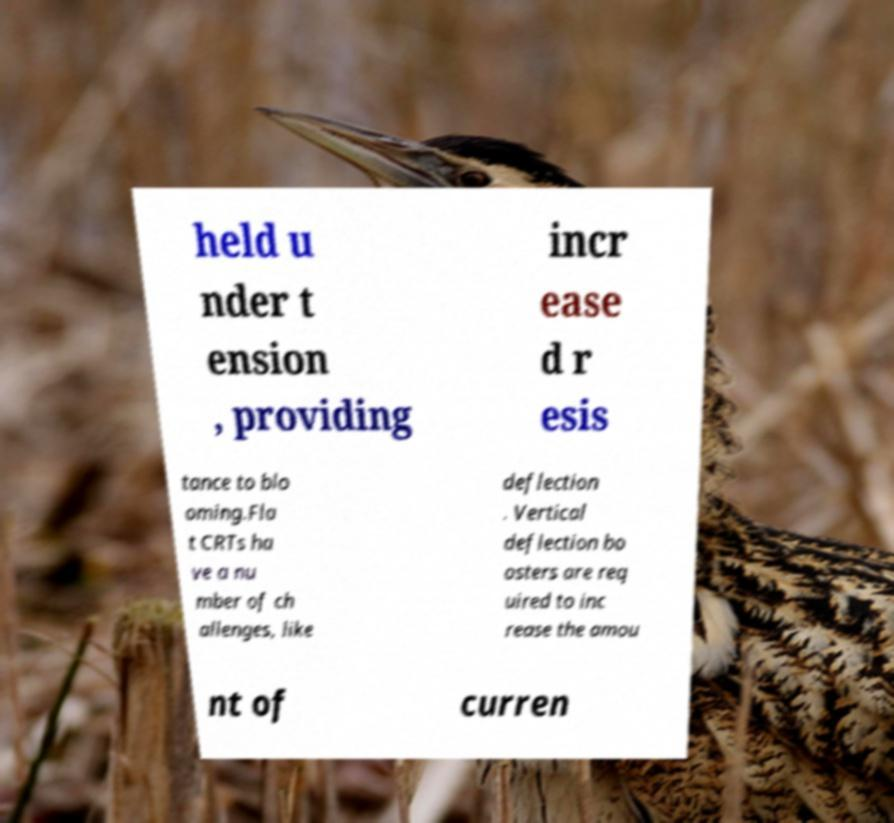Please read and relay the text visible in this image. What does it say? held u nder t ension , providing incr ease d r esis tance to blo oming.Fla t CRTs ha ve a nu mber of ch allenges, like deflection . Vertical deflection bo osters are req uired to inc rease the amou nt of curren 